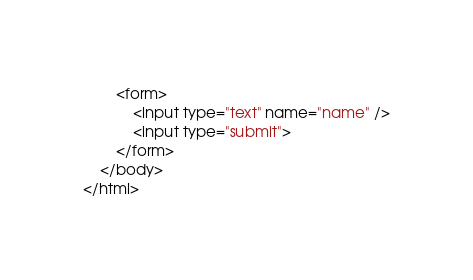<code> <loc_0><loc_0><loc_500><loc_500><_HTML_>        <form>
            <input type="text" name="name" />
            <input type="submit">
        </form>
    </body>
</html></code> 